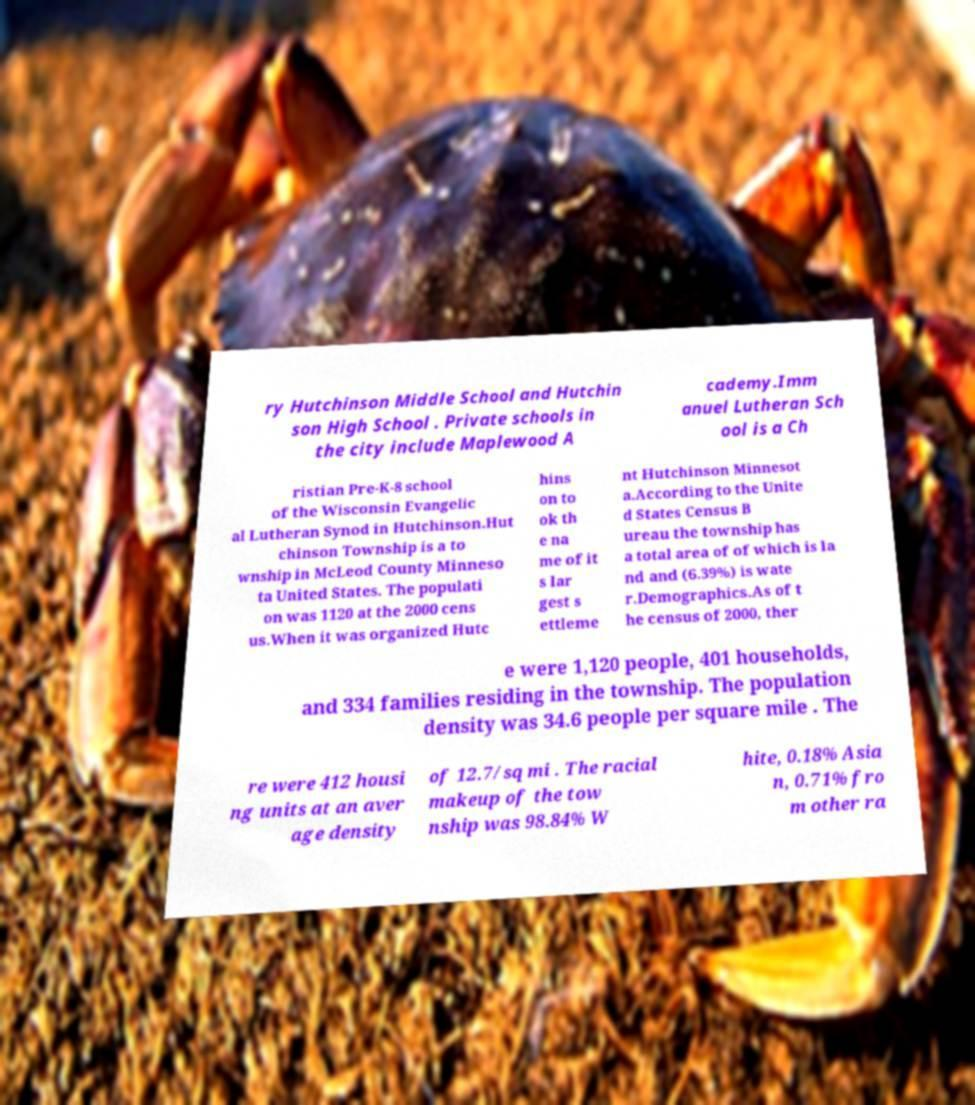Can you accurately transcribe the text from the provided image for me? ry Hutchinson Middle School and Hutchin son High School . Private schools in the city include Maplewood A cademy.Imm anuel Lutheran Sch ool is a Ch ristian Pre-K-8 school of the Wisconsin Evangelic al Lutheran Synod in Hutchinson.Hut chinson Township is a to wnship in McLeod County Minneso ta United States. The populati on was 1120 at the 2000 cens us.When it was organized Hutc hins on to ok th e na me of it s lar gest s ettleme nt Hutchinson Minnesot a.According to the Unite d States Census B ureau the township has a total area of of which is la nd and (6.39%) is wate r.Demographics.As of t he census of 2000, ther e were 1,120 people, 401 households, and 334 families residing in the township. The population density was 34.6 people per square mile . The re were 412 housi ng units at an aver age density of 12.7/sq mi . The racial makeup of the tow nship was 98.84% W hite, 0.18% Asia n, 0.71% fro m other ra 